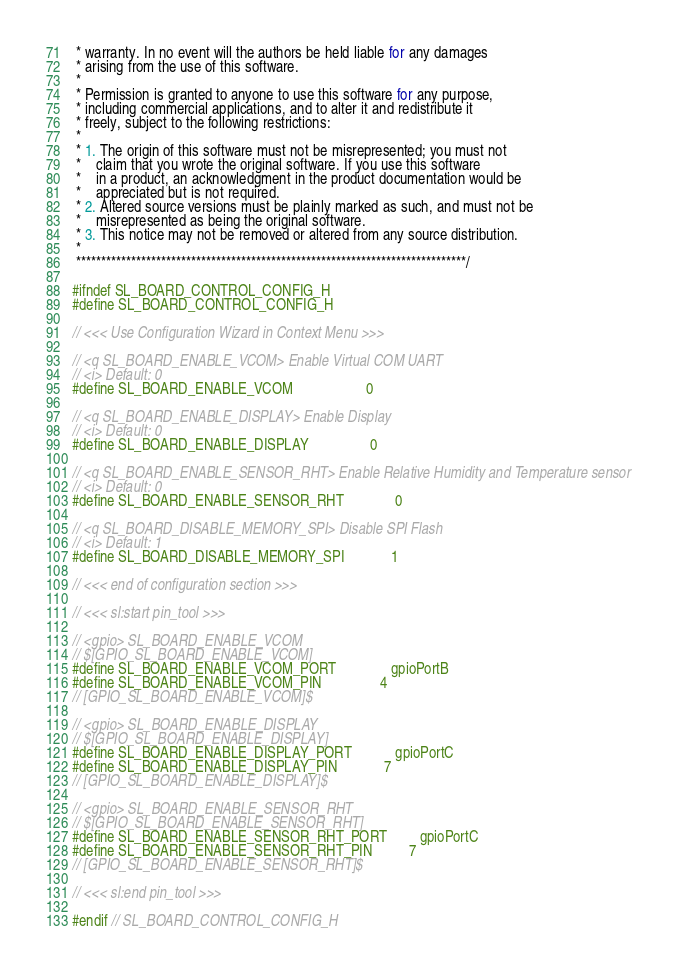Convert code to text. <code><loc_0><loc_0><loc_500><loc_500><_C_> * warranty. In no event will the authors be held liable for any damages
 * arising from the use of this software.
 *
 * Permission is granted to anyone to use this software for any purpose,
 * including commercial applications, and to alter it and redistribute it
 * freely, subject to the following restrictions:
 *
 * 1. The origin of this software must not be misrepresented; you must not
 *    claim that you wrote the original software. If you use this software
 *    in a product, an acknowledgment in the product documentation would be
 *    appreciated but is not required.
 * 2. Altered source versions must be plainly marked as such, and must not be
 *    misrepresented as being the original software.
 * 3. This notice may not be removed or altered from any source distribution.
 *
 ******************************************************************************/

#ifndef SL_BOARD_CONTROL_CONFIG_H
#define SL_BOARD_CONTROL_CONFIG_H

// <<< Use Configuration Wizard in Context Menu >>>

// <q SL_BOARD_ENABLE_VCOM> Enable Virtual COM UART
// <i> Default: 0
#define SL_BOARD_ENABLE_VCOM                    0

// <q SL_BOARD_ENABLE_DISPLAY> Enable Display
// <i> Default: 0
#define SL_BOARD_ENABLE_DISPLAY                 0

// <q SL_BOARD_ENABLE_SENSOR_RHT> Enable Relative Humidity and Temperature sensor
// <i> Default: 0
#define SL_BOARD_ENABLE_SENSOR_RHT              0

// <q SL_BOARD_DISABLE_MEMORY_SPI> Disable SPI Flash
// <i> Default: 1
#define SL_BOARD_DISABLE_MEMORY_SPI             1

// <<< end of configuration section >>>

// <<< sl:start pin_tool >>>

// <gpio> SL_BOARD_ENABLE_VCOM
// $[GPIO_SL_BOARD_ENABLE_VCOM]
#define SL_BOARD_ENABLE_VCOM_PORT               gpioPortB
#define SL_BOARD_ENABLE_VCOM_PIN                4
// [GPIO_SL_BOARD_ENABLE_VCOM]$

// <gpio> SL_BOARD_ENABLE_DISPLAY
// $[GPIO_SL_BOARD_ENABLE_DISPLAY]
#define SL_BOARD_ENABLE_DISPLAY_PORT            gpioPortC
#define SL_BOARD_ENABLE_DISPLAY_PIN             7
// [GPIO_SL_BOARD_ENABLE_DISPLAY]$

// <gpio> SL_BOARD_ENABLE_SENSOR_RHT
// $[GPIO_SL_BOARD_ENABLE_SENSOR_RHT]
#define SL_BOARD_ENABLE_SENSOR_RHT_PORT         gpioPortC
#define SL_BOARD_ENABLE_SENSOR_RHT_PIN          7
// [GPIO_SL_BOARD_ENABLE_SENSOR_RHT]$

// <<< sl:end pin_tool >>>

#endif // SL_BOARD_CONTROL_CONFIG_H
</code> 